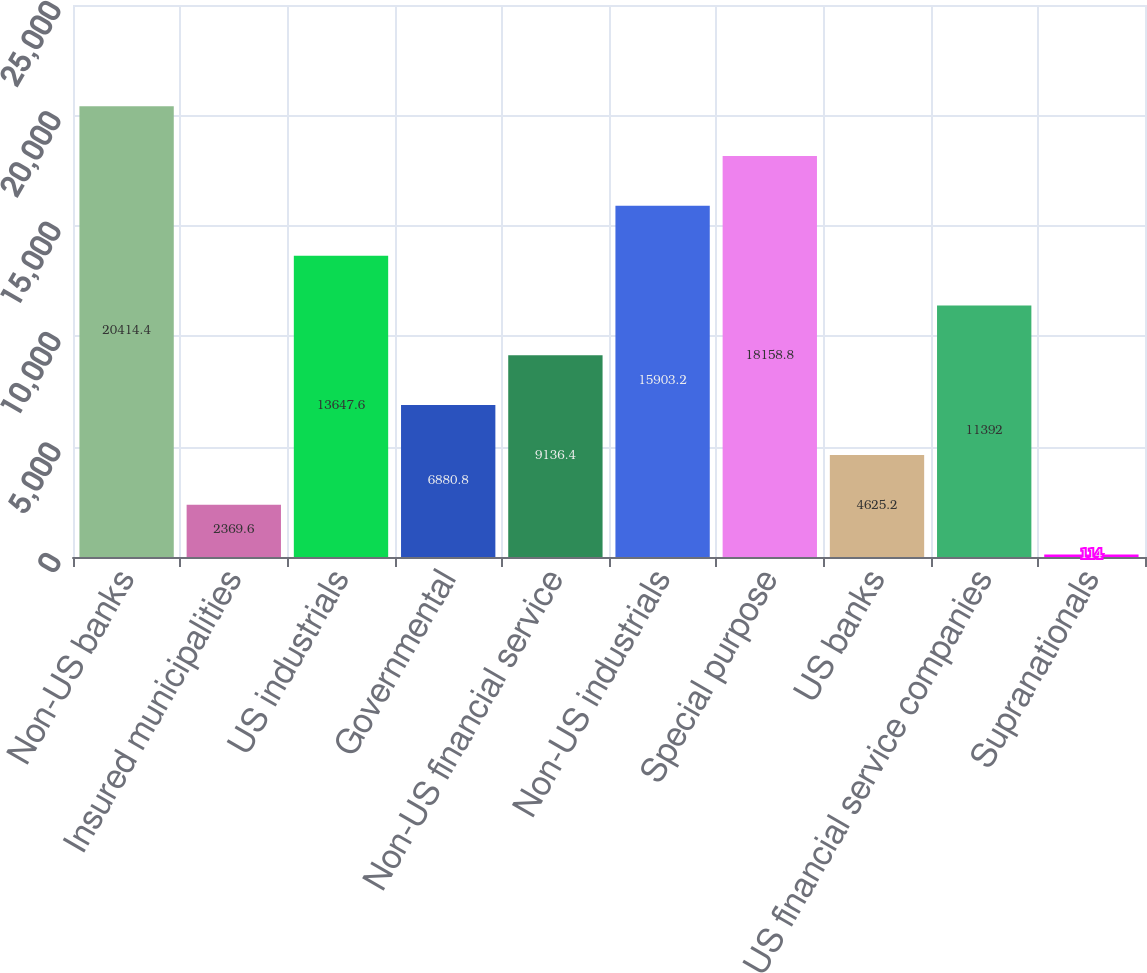Convert chart. <chart><loc_0><loc_0><loc_500><loc_500><bar_chart><fcel>Non-US banks<fcel>Insured municipalities<fcel>US industrials<fcel>Governmental<fcel>Non-US financial service<fcel>Non-US industrials<fcel>Special purpose<fcel>US banks<fcel>US financial service companies<fcel>Supranationals<nl><fcel>20414.4<fcel>2369.6<fcel>13647.6<fcel>6880.8<fcel>9136.4<fcel>15903.2<fcel>18158.8<fcel>4625.2<fcel>11392<fcel>114<nl></chart> 